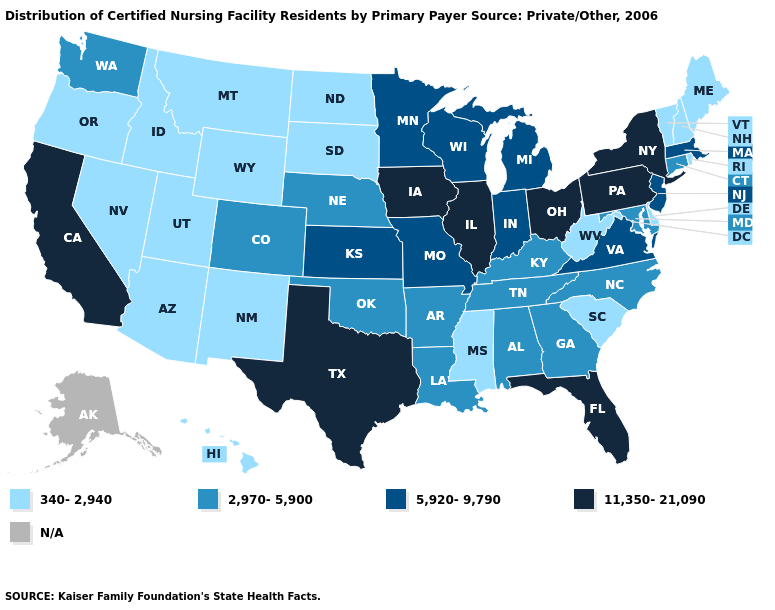Does California have the highest value in the USA?
Short answer required. Yes. Name the states that have a value in the range N/A?
Write a very short answer. Alaska. What is the lowest value in the Northeast?
Short answer required. 340-2,940. What is the value of Delaware?
Short answer required. 340-2,940. Does Florida have the lowest value in the USA?
Quick response, please. No. Name the states that have a value in the range 2,970-5,900?
Quick response, please. Alabama, Arkansas, Colorado, Connecticut, Georgia, Kentucky, Louisiana, Maryland, Nebraska, North Carolina, Oklahoma, Tennessee, Washington. What is the lowest value in states that border Massachusetts?
Short answer required. 340-2,940. Does the map have missing data?
Be succinct. Yes. What is the lowest value in the West?
Quick response, please. 340-2,940. Name the states that have a value in the range N/A?
Concise answer only. Alaska. Name the states that have a value in the range 5,920-9,790?
Be succinct. Indiana, Kansas, Massachusetts, Michigan, Minnesota, Missouri, New Jersey, Virginia, Wisconsin. 